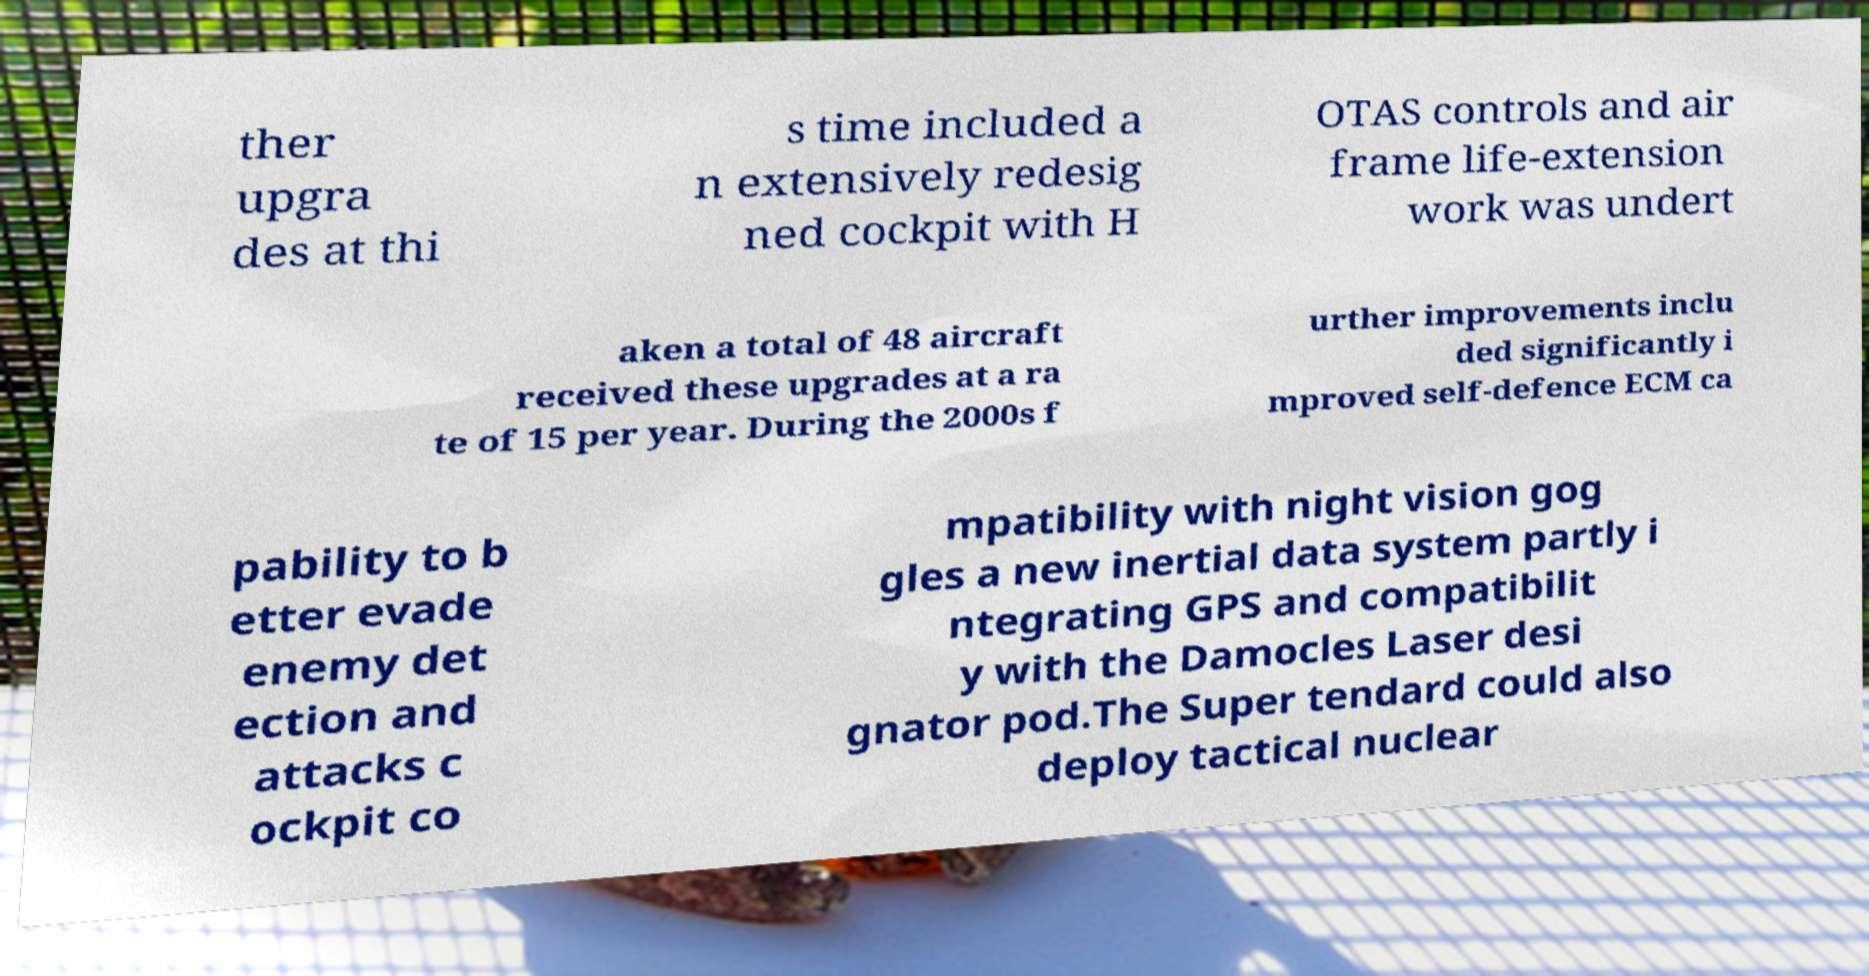What messages or text are displayed in this image? I need them in a readable, typed format. ther upgra des at thi s time included a n extensively redesig ned cockpit with H OTAS controls and air frame life-extension work was undert aken a total of 48 aircraft received these upgrades at a ra te of 15 per year. During the 2000s f urther improvements inclu ded significantly i mproved self-defence ECM ca pability to b etter evade enemy det ection and attacks c ockpit co mpatibility with night vision gog gles a new inertial data system partly i ntegrating GPS and compatibilit y with the Damocles Laser desi gnator pod.The Super tendard could also deploy tactical nuclear 